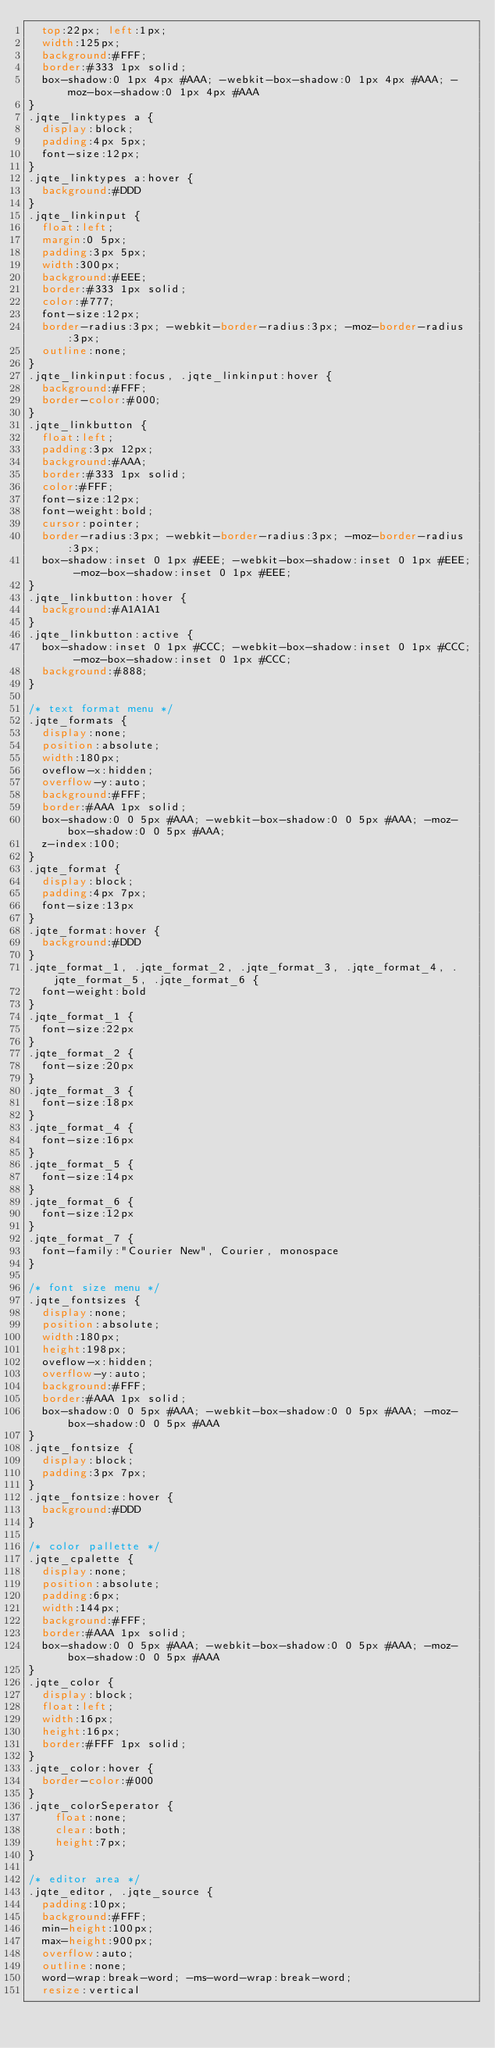Convert code to text. <code><loc_0><loc_0><loc_500><loc_500><_CSS_>	top:22px; left:1px;
	width:125px;
	background:#FFF;
	border:#333 1px solid;
	box-shadow:0 1px 4px #AAA; -webkit-box-shadow:0 1px 4px #AAA; -moz-box-shadow:0 1px 4px #AAA
}
.jqte_linktypes a {
	display:block;
	padding:4px 5px;
	font-size:12px;
}
.jqte_linktypes a:hover {
	background:#DDD
}
.jqte_linkinput {
	float:left;
	margin:0 5px;
	padding:3px 5px;
	width:300px;
	background:#EEE;
	border:#333 1px solid;
	color:#777;
	font-size:12px;
	border-radius:3px; -webkit-border-radius:3px; -moz-border-radius:3px;
	outline:none;
}
.jqte_linkinput:focus, .jqte_linkinput:hover {
	background:#FFF;
	border-color:#000;
}
.jqte_linkbutton {
	float:left;
	padding:3px 12px;
	background:#AAA;
	border:#333 1px solid;
	color:#FFF;
	font-size:12px;
	font-weight:bold;
	cursor:pointer;
	border-radius:3px; -webkit-border-radius:3px; -moz-border-radius:3px;
	box-shadow:inset 0 1px #EEE; -webkit-box-shadow:inset 0 1px #EEE; -moz-box-shadow:inset 0 1px #EEE;
}
.jqte_linkbutton:hover {
	background:#A1A1A1
}
.jqte_linkbutton:active {
	box-shadow:inset 0 1px #CCC; -webkit-box-shadow:inset 0 1px #CCC; -moz-box-shadow:inset 0 1px #CCC;
	background:#888;
}

/* text format menu */
.jqte_formats {
	display:none;
	position:absolute;
	width:180px;
	oveflow-x:hidden;
	overflow-y:auto;
	background:#FFF;
	border:#AAA 1px solid;
	box-shadow:0 0 5px #AAA; -webkit-box-shadow:0 0 5px #AAA; -moz-box-shadow:0 0 5px #AAA;
	z-index:100;
}
.jqte_format {
	display:block;
	padding:4px 7px;
	font-size:13px
}
.jqte_format:hover {
	background:#DDD
}
.jqte_format_1, .jqte_format_2, .jqte_format_3, .jqte_format_4, .jqte_format_5, .jqte_format_6 {
	font-weight:bold
}
.jqte_format_1 {
	font-size:22px
}
.jqte_format_2 {
	font-size:20px
}
.jqte_format_3 {
	font-size:18px
}
.jqte_format_4 {
	font-size:16px
}
.jqte_format_5 {
	font-size:14px
}
.jqte_format_6 {
	font-size:12px
}
.jqte_format_7 {
	font-family:"Courier New", Courier, monospace
}

/* font size menu */
.jqte_fontsizes {
	display:none;
	position:absolute;
	width:180px;
	height:198px;
	oveflow-x:hidden;
	overflow-y:auto;
	background:#FFF;
	border:#AAA 1px solid;
	box-shadow:0 0 5px #AAA; -webkit-box-shadow:0 0 5px #AAA; -moz-box-shadow:0 0 5px #AAA
}
.jqte_fontsize {
	display:block;
	padding:3px 7px;
}
.jqte_fontsize:hover {
	background:#DDD
}

/* color pallette */
.jqte_cpalette {
	display:none;
	position:absolute;
	padding:6px;
	width:144px;
	background:#FFF;
	border:#AAA 1px solid;
	box-shadow:0 0 5px #AAA; -webkit-box-shadow:0 0 5px #AAA; -moz-box-shadow:0 0 5px #AAA
}
.jqte_color {
	display:block;
	float:left;
	width:16px;
	height:16px;
	border:#FFF 1px solid;
}
.jqte_color:hover {
	border-color:#000
}
.jqte_colorSeperator {
    float:none;
    clear:both;
    height:7px;
}

/* editor area */
.jqte_editor, .jqte_source {
	padding:10px;
	background:#FFF;
	min-height:100px;
	max-height:900px;
	overflow:auto;
	outline:none;
	word-wrap:break-word; -ms-word-wrap:break-word;
	resize:vertical</code> 